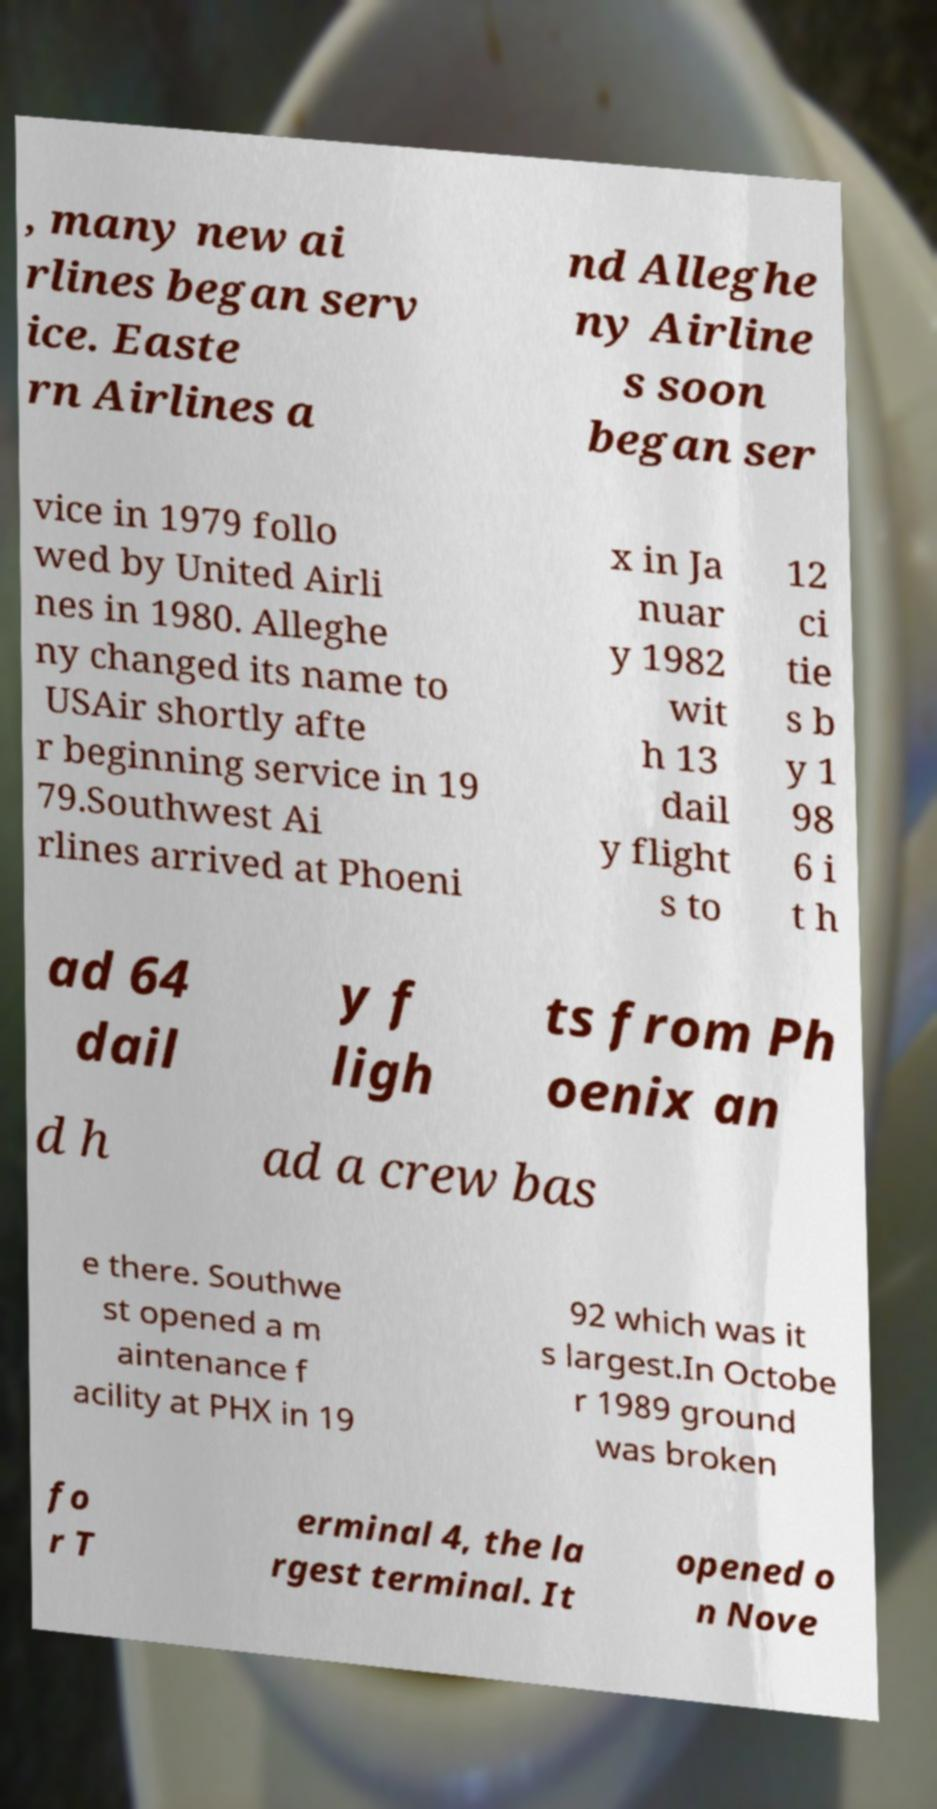Could you extract and type out the text from this image? , many new ai rlines began serv ice. Easte rn Airlines a nd Alleghe ny Airline s soon began ser vice in 1979 follo wed by United Airli nes in 1980. Alleghe ny changed its name to USAir shortly afte r beginning service in 19 79.Southwest Ai rlines arrived at Phoeni x in Ja nuar y 1982 wit h 13 dail y flight s to 12 ci tie s b y 1 98 6 i t h ad 64 dail y f ligh ts from Ph oenix an d h ad a crew bas e there. Southwe st opened a m aintenance f acility at PHX in 19 92 which was it s largest.In Octobe r 1989 ground was broken fo r T erminal 4, the la rgest terminal. It opened o n Nove 